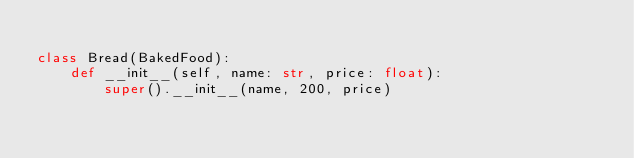Convert code to text. <code><loc_0><loc_0><loc_500><loc_500><_Python_>
class Bread(BakedFood):
    def __init__(self, name: str, price: float):
        super().__init__(name, 200, price)
</code> 